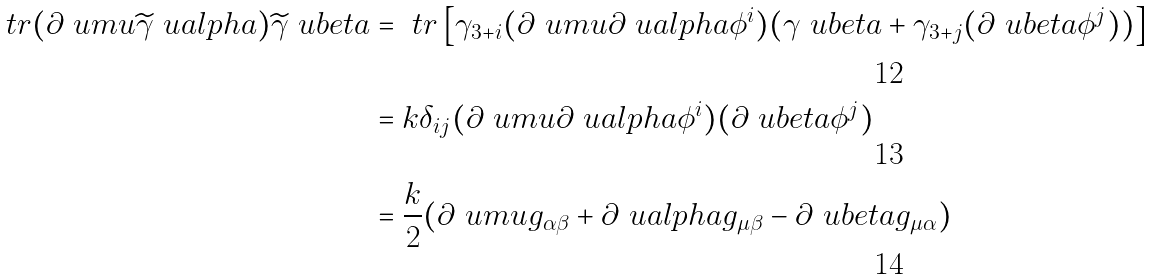Convert formula to latex. <formula><loc_0><loc_0><loc_500><loc_500>\ t r ( \partial \ u m u \widetilde { \gamma } \ u a l p h a ) \widetilde { \gamma } \ u b e t a & = \ t r \left [ \gamma _ { 3 + i } ( \partial \ u m u \partial \ u a l p h a \phi ^ { i } ) ( \gamma \ u b e t a + \gamma _ { 3 + j } ( \partial \ u b e t a \phi ^ { j } ) ) \right ] \\ & = k \delta _ { i j } ( \partial \ u m u \partial \ u a l p h a \phi ^ { i } ) ( \partial \ u b e t a \phi ^ { j } ) \\ & = \frac { k } { 2 } ( \partial \ u m u g _ { \alpha \beta } + \partial \ u a l p h a g _ { \mu \beta } - \partial \ u b e t a g _ { \mu \alpha } )</formula> 